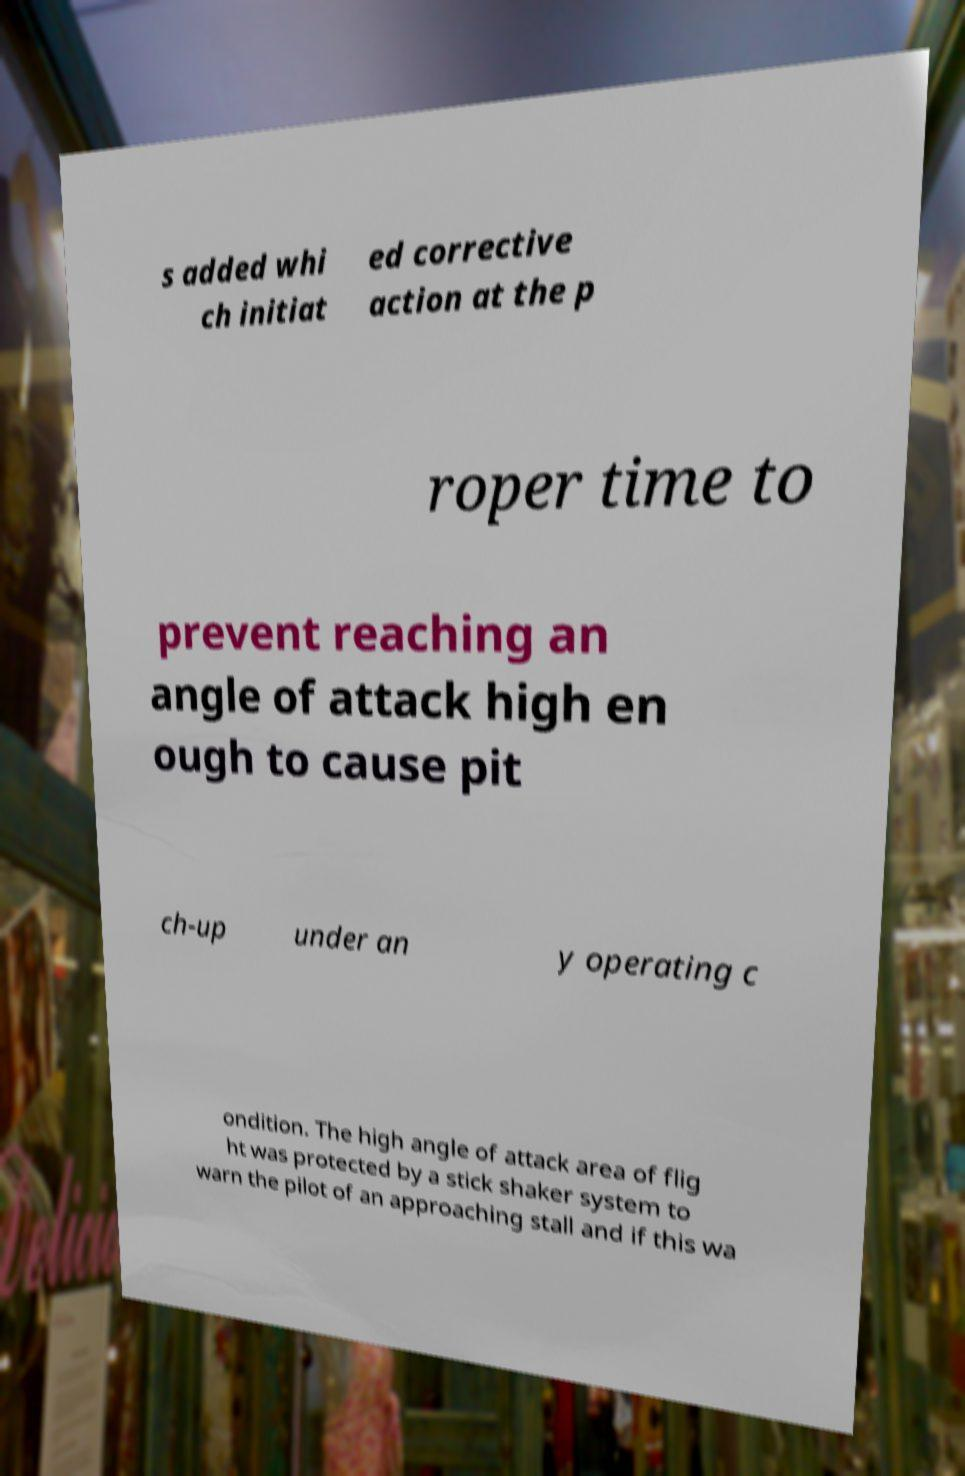There's text embedded in this image that I need extracted. Can you transcribe it verbatim? s added whi ch initiat ed corrective action at the p roper time to prevent reaching an angle of attack high en ough to cause pit ch-up under an y operating c ondition. The high angle of attack area of flig ht was protected by a stick shaker system to warn the pilot of an approaching stall and if this wa 